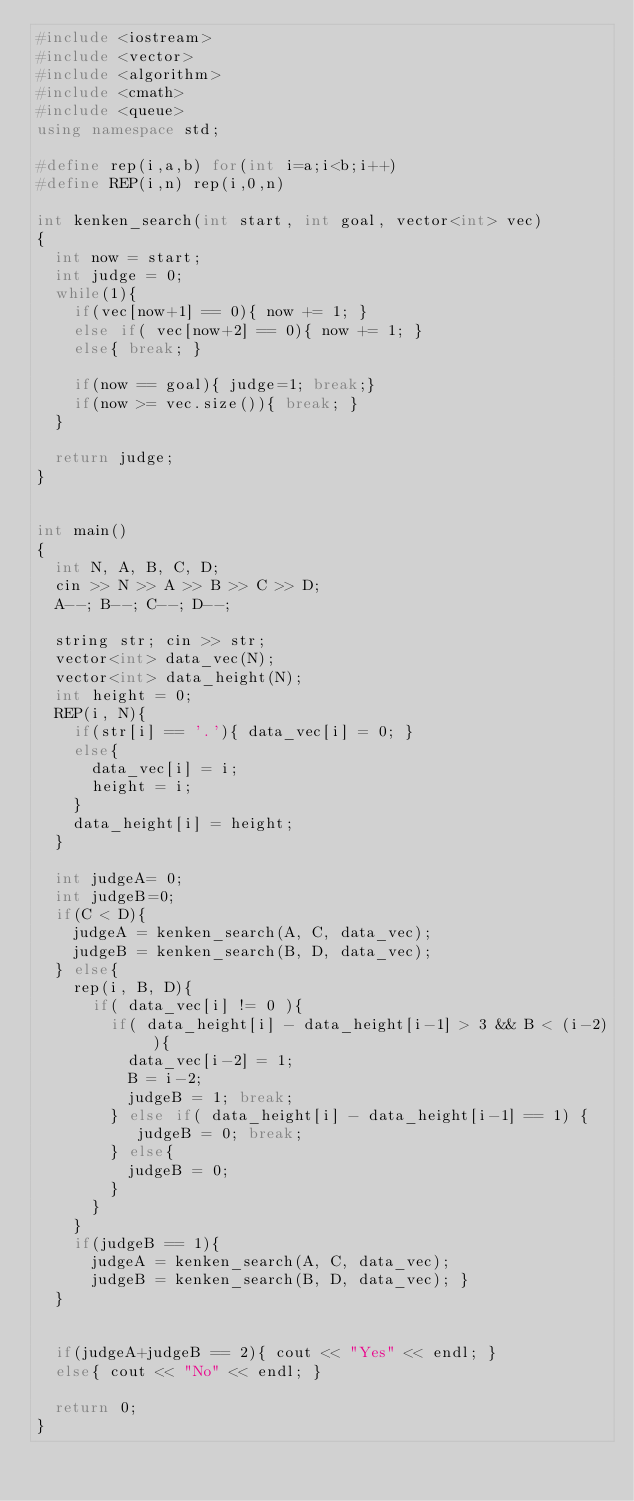Convert code to text. <code><loc_0><loc_0><loc_500><loc_500><_C++_>#include <iostream>
#include <vector>
#include <algorithm>
#include <cmath>
#include <queue>
using namespace std;

#define rep(i,a,b) for(int i=a;i<b;i++)
#define REP(i,n) rep(i,0,n)

int kenken_search(int start, int goal, vector<int> vec)
{
  int now = start;
  int judge = 0;
  while(1){
    if(vec[now+1] == 0){ now += 1; }
    else if( vec[now+2] == 0){ now += 1; }
    else{ break; }

    if(now == goal){ judge=1; break;}
    if(now >= vec.size()){ break; }
  }

  return judge;
}


int main()
{
  int N, A, B, C, D;
  cin >> N >> A >> B >> C >> D;
  A--; B--; C--; D--;

  string str; cin >> str;
  vector<int> data_vec(N);
  vector<int> data_height(N);
  int height = 0;
  REP(i, N){ 
    if(str[i] == '.'){ data_vec[i] = 0; }
    else{
      data_vec[i] = i;
      height = i; 
    }
    data_height[i] = height;
  }

  int judgeA= 0;
  int judgeB=0;
  if(C < D){
    judgeA = kenken_search(A, C, data_vec);
    judgeB = kenken_search(B, D, data_vec);
  } else{
    rep(i, B, D){
      if( data_vec[i] != 0 ){
        if( data_height[i] - data_height[i-1] > 3 && B < (i-2) ){ 
          data_vec[i-2] = 1;
          B = i-2;
          judgeB = 1; break;
        } else if( data_height[i] - data_height[i-1] == 1) {
           judgeB = 0; break; 
        } else{
          judgeB = 0;
        }
      }
    }
    if(judgeB == 1){ 
      judgeA = kenken_search(A, C, data_vec);
      judgeB = kenken_search(B, D, data_vec); }
  }


  if(judgeA+judgeB == 2){ cout << "Yes" << endl; }
  else{ cout << "No" << endl; }

  return 0;
}</code> 